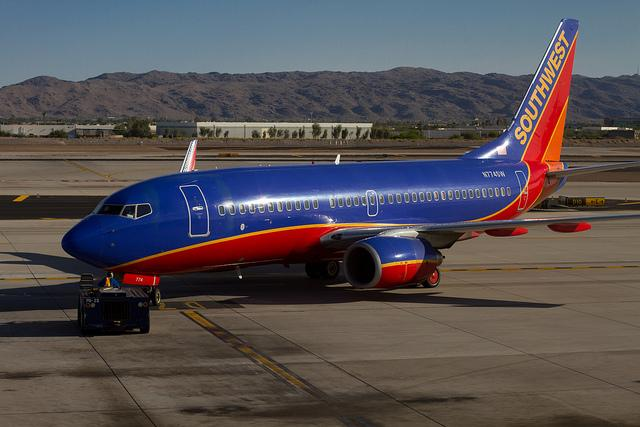Where is the plane stopped? Please explain your reasoning. tarmac. The tarmac is where planes go to land and drive around to a terminal. 